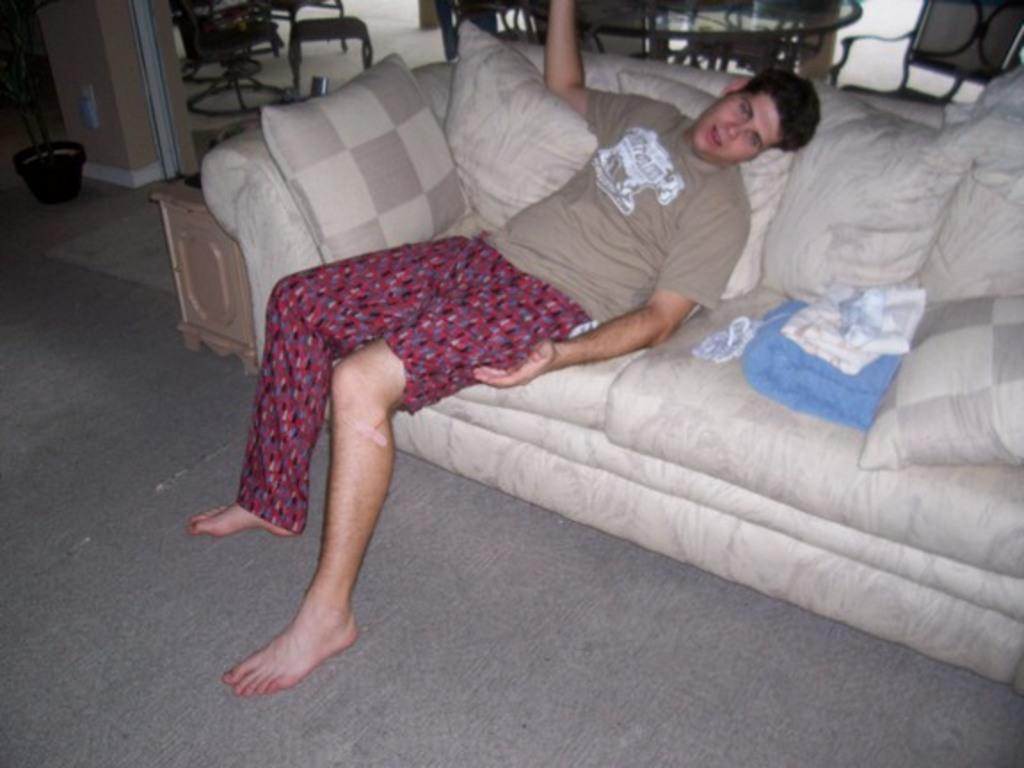What is the person in the image doing? There is a person sitting on the sofa in the image. What is on the sofa with the person? There are pillows on the sofa. What furniture can be seen in the background? There are chairs and a table in the background. What type of plant is visible on the floor? There is a house plant on the floor. What does the cow smell like in the image? There is no cow present in the image, so it is not possible to determine what it might smell like. 